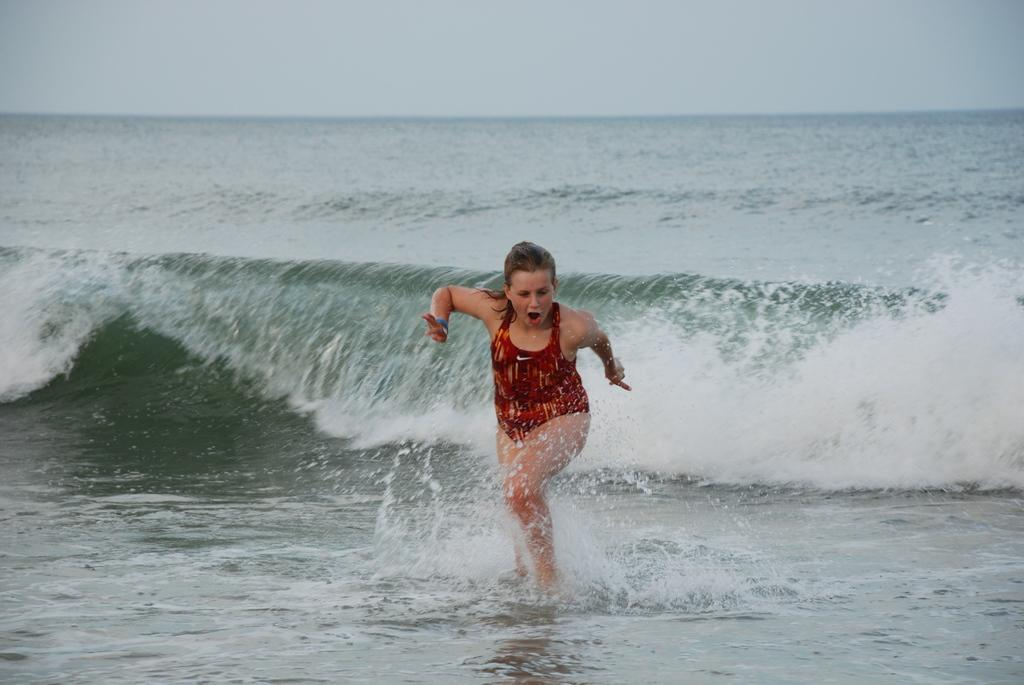Who is the main subject in the image? There is a woman in the image. What is the woman doing in the image? The woman is running. What can be seen in the background of the image? Water and the sky are visible in the background of the image. What type of cheese is the woman holding while running in the image? There is no cheese present in the image; the woman is running without holding anything. 